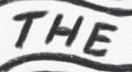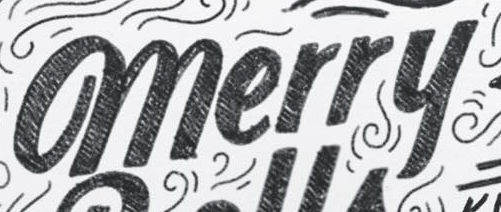What words can you see in these images in sequence, separated by a semicolon? THE; merry 